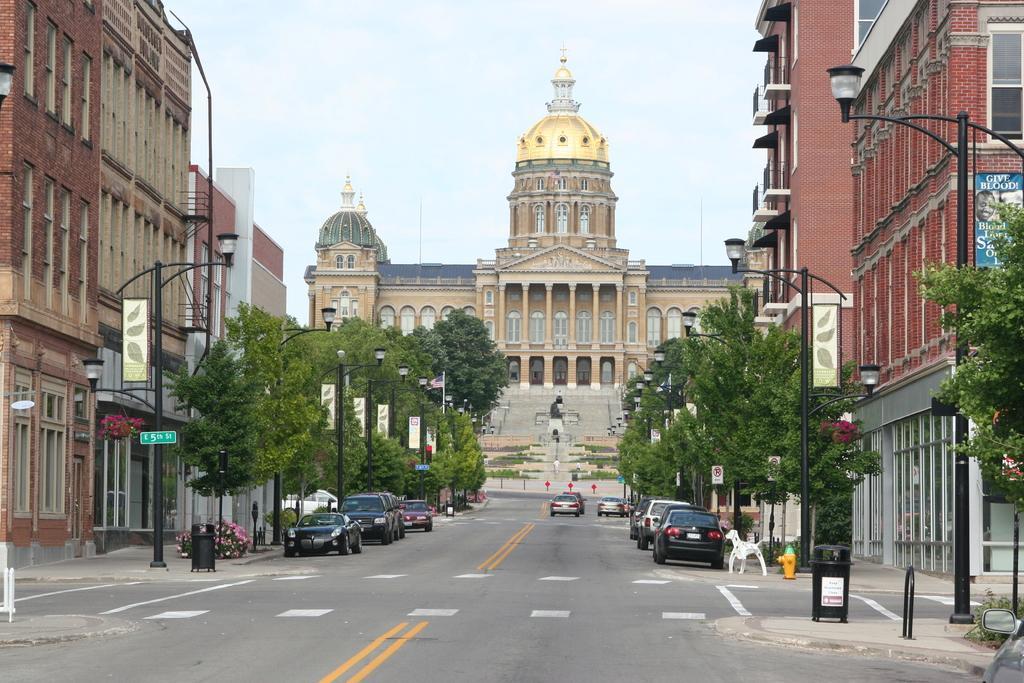How would you summarize this image in a sentence or two? In this image we can see a vehicles which are moving on road, there are some cars which are parked on road on left and right side of the image, there are some street lights, tree, buildings also on left and right side of the image and in the background of the image there is a palace and stairs. 